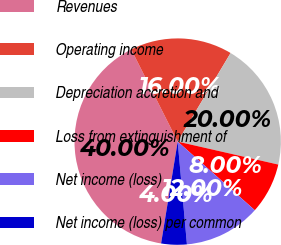<chart> <loc_0><loc_0><loc_500><loc_500><pie_chart><fcel>Revenues<fcel>Operating income<fcel>Depreciation accretion and<fcel>Loss from extinguishment of<fcel>Net income (loss)<fcel>Net income (loss) per common<nl><fcel>40.0%<fcel>16.0%<fcel>20.0%<fcel>8.0%<fcel>12.0%<fcel>4.0%<nl></chart> 